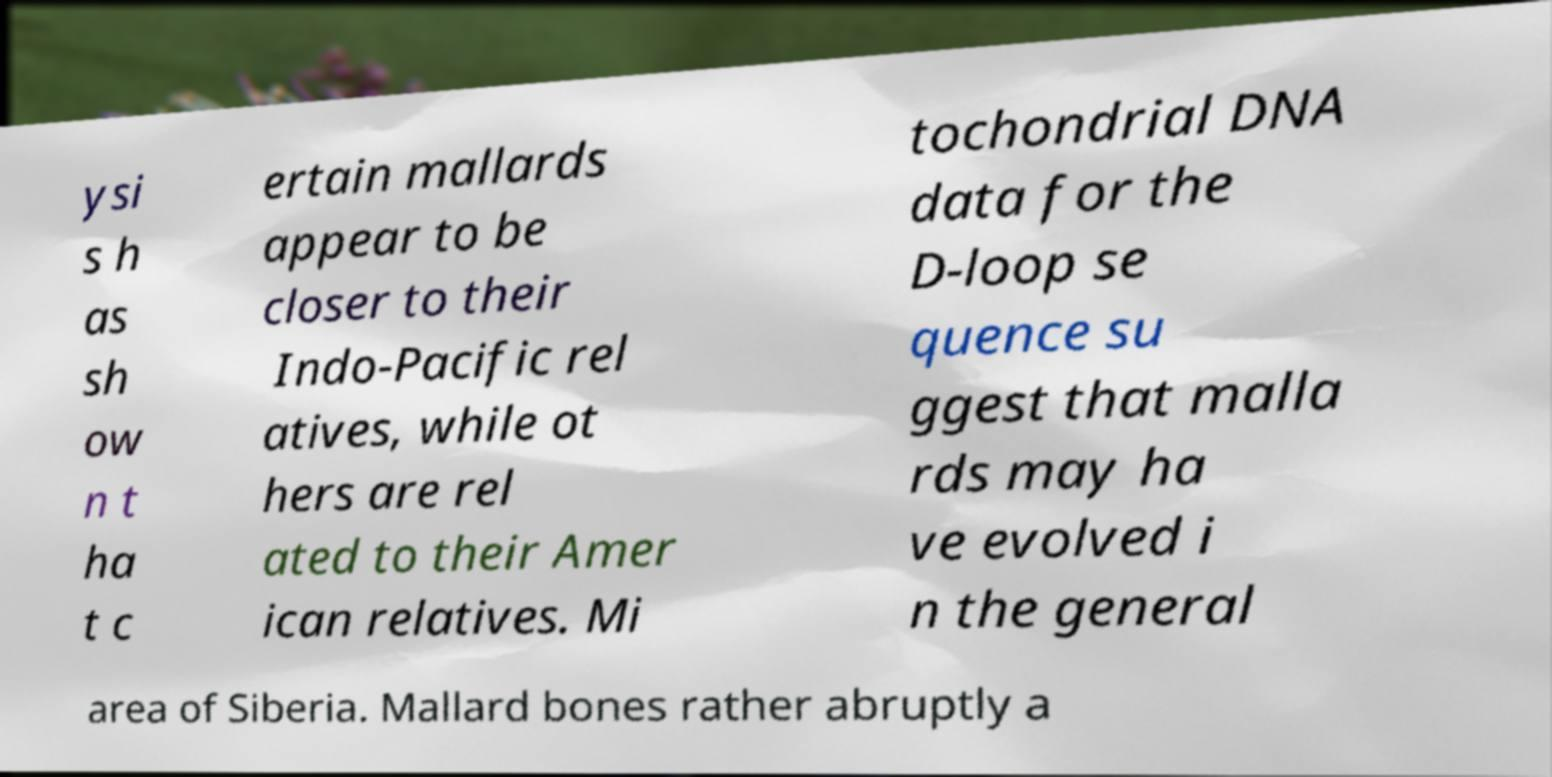Please read and relay the text visible in this image. What does it say? ysi s h as sh ow n t ha t c ertain mallards appear to be closer to their Indo-Pacific rel atives, while ot hers are rel ated to their Amer ican relatives. Mi tochondrial DNA data for the D-loop se quence su ggest that malla rds may ha ve evolved i n the general area of Siberia. Mallard bones rather abruptly a 